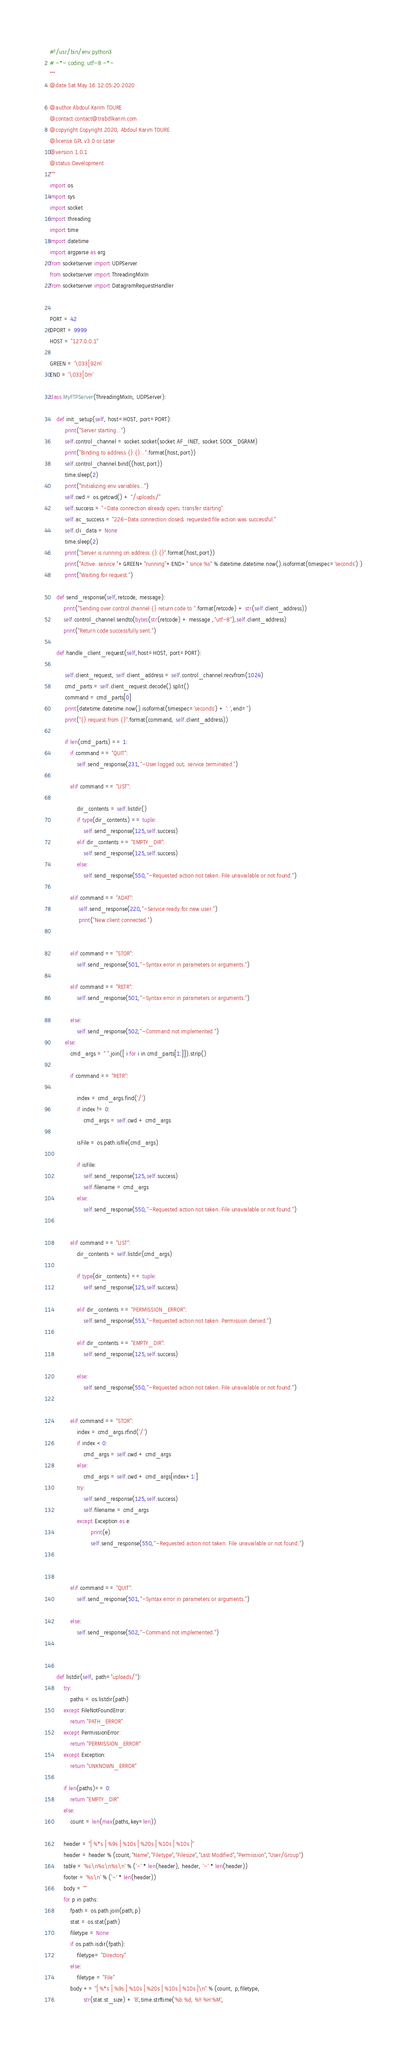Convert code to text. <code><loc_0><loc_0><loc_500><loc_500><_Python_>#!/usr/bin/env python3
# -*- coding: utf-8 -*-
"""
@date Sat May 16 12:05:20 2020

@author Abdoul Karim TOURE
@contact contact@trabdlkarim.com
@copyright Copyright 2020, Abdoul Karim TOURE
@license GPL v3.0 or Later
@version 1.0.1
@status Development
"""
import os
import sys
import socket
import threading
import time
import datetime
import argparse as arg
from socketserver import UDPServer
from socketserver import ThreadingMixIn
from socketserver import DatagramRequestHandler


PORT = 42
DPORT = 9999
HOST = "127.0.0.1"

GREEN = '\033[92m'
END = '\033[0m'

class MyFTPServer(ThreadingMixIn, UDPServer):

    def init_setup(self, host=HOST, port=PORT):
         print("Server starting...")
         self.control_channel = socket.socket(socket.AF_INET, socket.SOCK_DGRAM)
         print("Binding to address {}:{}...".format(host,port))
         self.control_channel.bind((host,port))
         time.sleep(2)
         print("Initializing env variables...")
         self.cwd = os.getcwd() + "/uploads/"
         self.success = "-Data connection already open; transfer starting"
         self.ac_success = "226-Data connection closed; requested file action was successful."
         self.cli_data = None
         time.sleep(2)
         print("Server is running on address {}:{}".format(host,port))
         print("Active: service "+GREEN+"running"+END+" since %s" % datetime.datetime.now().isoformat(timespec='seconds') )
         print("Waiting for request.")

    def send_response(self,retcode, message):
        print("Sending over control channel {} return code to ".format(retcode) + str(self.client_address))
        self.control_channel.sendto(bytes(str(retcode) + message ,"utf-8"),self.client_address)
        print("Return code successfully sent.")

    def handle_client_request(self,host=HOST, port=PORT):

         self.client_request, self.client_address = self.control_channel.recvfrom(1024)
         cmd_parts = self.client_request.decode().split()
         command = cmd_parts[0]
         print(datetime.datetime.now().isoformat(timespec='seconds') + ': ',end='')
         print("{} request from {}".format(command, self.client_address))

         if len(cmd_parts) == 1:
            if command == "QUIT":
                self.send_response(231,"-User logged out; service terminated.")

            elif command == "LIST":

                dir_contents = self.listdir()
                if type(dir_contents) == tuple:
                    self.send_response(125,self.success)
                elif dir_contents == "EMPTY_DIR":
                    self.send_response(125,self.success)
                else:
                    self.send_response(550,"-Requested action not taken. File unavailable or not found.")

            elif command == "ADAT":
                 self.send_response(220,"-Service ready for new user.")
                 print("New client connected.")


            elif command == "STOR":
                self.send_response(501,"-Syntax error in parameters or arguments.")

            elif command == "RETR":
                self.send_response(501,"-Syntax error in parameters or arguments.")

            else:
                self.send_response(502,"-Command not implemented.")
         else:
            cmd_args = " ".join([ i for i in cmd_parts[1:]]).strip()

            if command == "RETR":

                index = cmd_args.find('/')
                if index != 0:
                    cmd_args = self.cwd + cmd_args

                isFile = os.path.isfile(cmd_args)

                if isFile:
                    self.send_response(125,self.success)
                    self.filename = cmd_args
                else:
                    self.send_response(550,"-Requested action not taken. File unavailable or not found.")


            elif command == "LIST":
                dir_contents = self.listdir(cmd_args)

                if type(dir_contents) == tuple:
                    self.send_response(125,self.success)

                elif dir_contents == "PERMISSION_ERROR":
                    self.send_response(553,"-Requested action not taken. Permission denied.")

                elif dir_contents == "EMPTY_DIR":
                    self.send_response(125,self.success)

                else:
                    self.send_response(550,"-Requested action not taken. File unavailable or not found.")


            elif command == "STOR":
                index = cmd_args.rfind('/')
                if index < 0:
                    cmd_args = self.cwd + cmd_args
                else:
                    cmd_args = self.cwd + cmd_args[index+1:]
                try:
                    self.send_response(125,self.success)
                    self.filename = cmd_args
                except Exception as e:
                        print(e)
                        self.send_response(550,"-Requested action not taken. File unavailable or not found.")



            elif command == "QUIT":
                self.send_response(501,"-Syntax error in parameters or arguments.")

            else:
                self.send_response(502,"-Command not implemented.")



    def listdir(self, path="uploads/"):
        try:
            paths = os.listdir(path)
        except FileNotFoundError:
            return "PATH_ERROR"
        except PermissionError:
            return "PERMISSION_ERROR"
        except Exception:
            return "UNKNOWN_ERROR"

        if len(paths)== 0:
            return "EMPTY_DIR"
        else:
            count = len(max(paths,key=len))

        header = "| %*s | %9s | %10s | %20s | %10s | %10s |"
        header = header % (count,"Name","Filetype","Filesize","Last Modified","Permission","User/Group")
        table = '%s\n%s\n%s\n' % ('-' * len(header), header, '-' * len(header))
        footer = '%s\n' % ('-' * len(header))
        body = ""
        for p in paths:
            fpath = os.path.join(path,p)
            stat = os.stat(path)
            filetype = None
            if os.path.isdir(fpath):
                filetype= "Directory"
            else:
                filetype = "File"
            body += "| %*s | %9s | %10s | %20s | %10s | %10s |\n" % (count, p,filetype,
                    str(stat.st_size) + 'B',time.strftime('%b %d, %Y %H:%M',</code> 